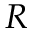<formula> <loc_0><loc_0><loc_500><loc_500>R</formula> 